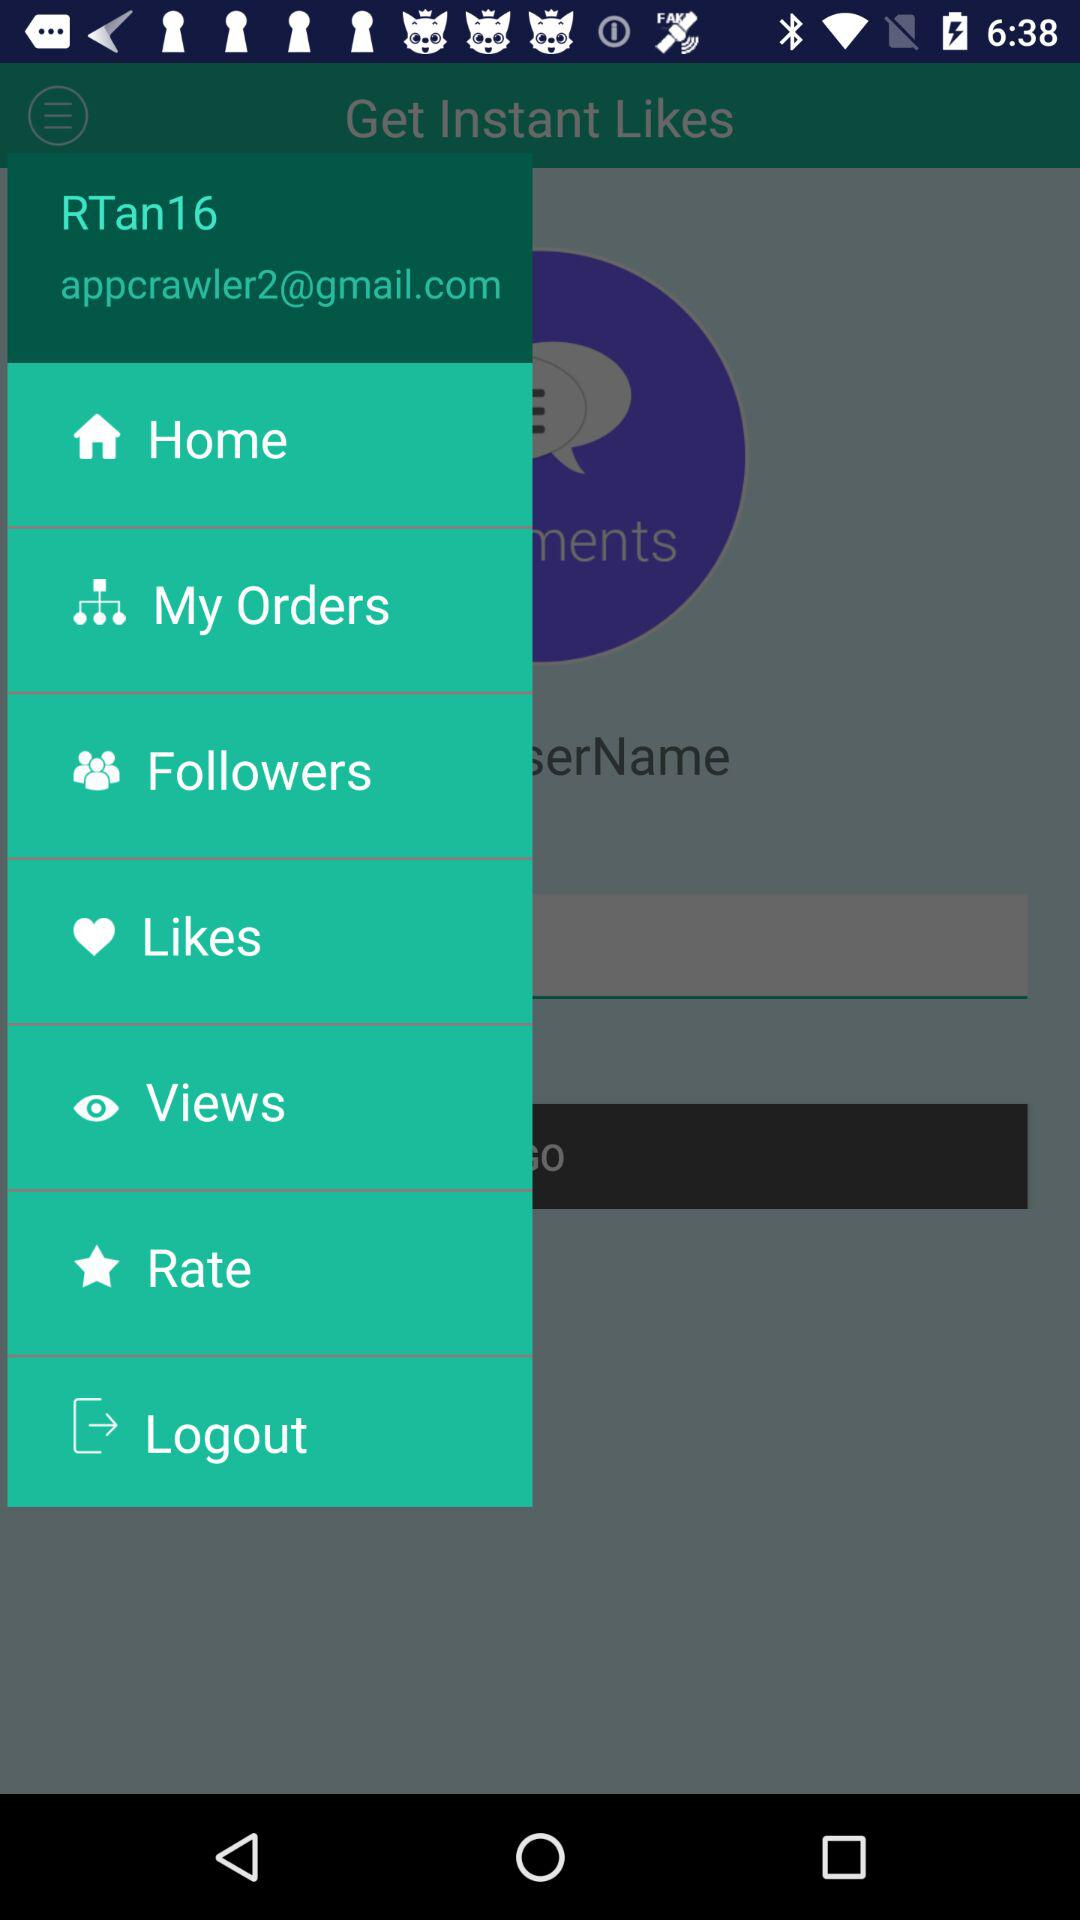What is the username?
Answer the question using a single word or phrase. The username is "RTan16" 